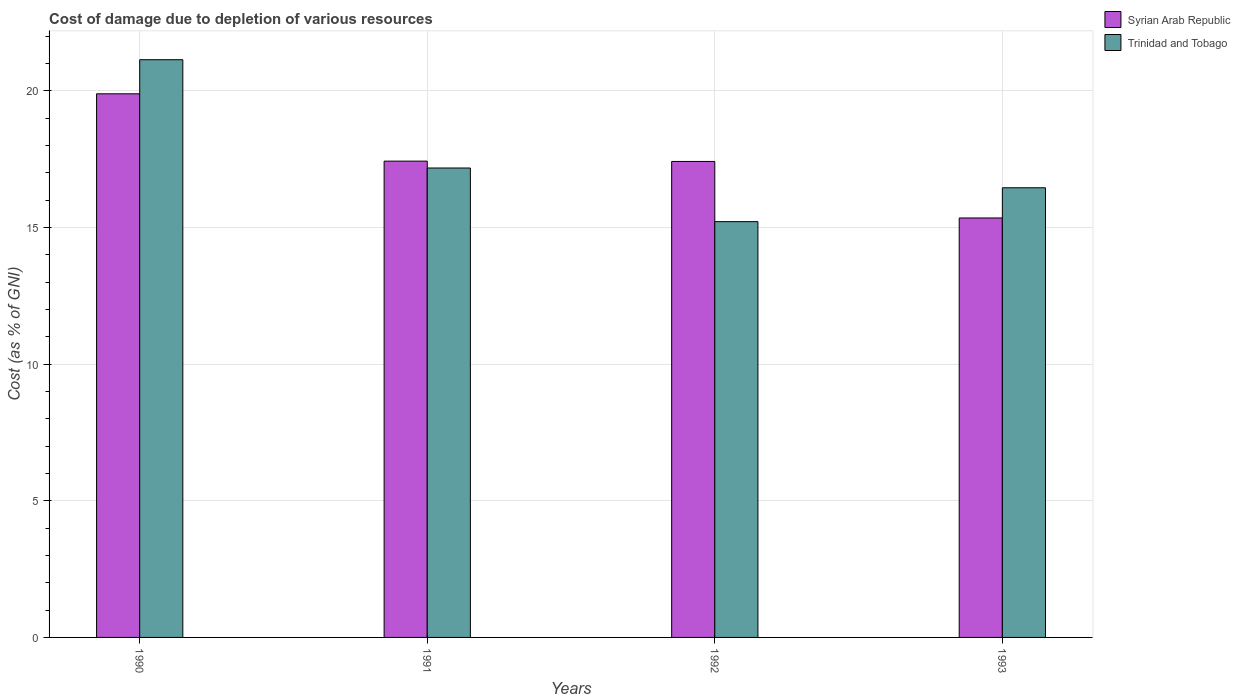How many groups of bars are there?
Provide a succinct answer. 4. Are the number of bars on each tick of the X-axis equal?
Give a very brief answer. Yes. How many bars are there on the 2nd tick from the right?
Keep it short and to the point. 2. What is the label of the 3rd group of bars from the left?
Ensure brevity in your answer.  1992. What is the cost of damage caused due to the depletion of various resources in Syrian Arab Republic in 1992?
Keep it short and to the point. 17.41. Across all years, what is the maximum cost of damage caused due to the depletion of various resources in Syrian Arab Republic?
Give a very brief answer. 19.89. Across all years, what is the minimum cost of damage caused due to the depletion of various resources in Syrian Arab Republic?
Provide a short and direct response. 15.34. In which year was the cost of damage caused due to the depletion of various resources in Trinidad and Tobago maximum?
Your answer should be very brief. 1990. What is the total cost of damage caused due to the depletion of various resources in Trinidad and Tobago in the graph?
Provide a succinct answer. 69.96. What is the difference between the cost of damage caused due to the depletion of various resources in Trinidad and Tobago in 1990 and that in 1993?
Make the answer very short. 4.68. What is the difference between the cost of damage caused due to the depletion of various resources in Syrian Arab Republic in 1993 and the cost of damage caused due to the depletion of various resources in Trinidad and Tobago in 1991?
Provide a short and direct response. -1.83. What is the average cost of damage caused due to the depletion of various resources in Trinidad and Tobago per year?
Give a very brief answer. 17.49. In the year 1993, what is the difference between the cost of damage caused due to the depletion of various resources in Trinidad and Tobago and cost of damage caused due to the depletion of various resources in Syrian Arab Republic?
Your response must be concise. 1.1. What is the ratio of the cost of damage caused due to the depletion of various resources in Trinidad and Tobago in 1990 to that in 1993?
Keep it short and to the point. 1.28. What is the difference between the highest and the second highest cost of damage caused due to the depletion of various resources in Trinidad and Tobago?
Give a very brief answer. 3.96. What is the difference between the highest and the lowest cost of damage caused due to the depletion of various resources in Trinidad and Tobago?
Ensure brevity in your answer.  5.92. In how many years, is the cost of damage caused due to the depletion of various resources in Syrian Arab Republic greater than the average cost of damage caused due to the depletion of various resources in Syrian Arab Republic taken over all years?
Give a very brief answer. 1. What does the 2nd bar from the left in 1992 represents?
Provide a succinct answer. Trinidad and Tobago. What does the 1st bar from the right in 1991 represents?
Offer a terse response. Trinidad and Tobago. What is the difference between two consecutive major ticks on the Y-axis?
Make the answer very short. 5. Are the values on the major ticks of Y-axis written in scientific E-notation?
Your answer should be compact. No. Does the graph contain grids?
Your response must be concise. Yes. How many legend labels are there?
Provide a short and direct response. 2. What is the title of the graph?
Provide a succinct answer. Cost of damage due to depletion of various resources. Does "Azerbaijan" appear as one of the legend labels in the graph?
Provide a succinct answer. No. What is the label or title of the X-axis?
Make the answer very short. Years. What is the label or title of the Y-axis?
Your answer should be compact. Cost (as % of GNI). What is the Cost (as % of GNI) in Syrian Arab Republic in 1990?
Your answer should be very brief. 19.89. What is the Cost (as % of GNI) of Trinidad and Tobago in 1990?
Provide a short and direct response. 21.13. What is the Cost (as % of GNI) of Syrian Arab Republic in 1991?
Give a very brief answer. 17.42. What is the Cost (as % of GNI) of Trinidad and Tobago in 1991?
Ensure brevity in your answer.  17.17. What is the Cost (as % of GNI) of Syrian Arab Republic in 1992?
Provide a short and direct response. 17.41. What is the Cost (as % of GNI) in Trinidad and Tobago in 1992?
Provide a succinct answer. 15.21. What is the Cost (as % of GNI) of Syrian Arab Republic in 1993?
Provide a short and direct response. 15.34. What is the Cost (as % of GNI) in Trinidad and Tobago in 1993?
Your answer should be compact. 16.45. Across all years, what is the maximum Cost (as % of GNI) in Syrian Arab Republic?
Ensure brevity in your answer.  19.89. Across all years, what is the maximum Cost (as % of GNI) of Trinidad and Tobago?
Your response must be concise. 21.13. Across all years, what is the minimum Cost (as % of GNI) in Syrian Arab Republic?
Offer a terse response. 15.34. Across all years, what is the minimum Cost (as % of GNI) in Trinidad and Tobago?
Provide a succinct answer. 15.21. What is the total Cost (as % of GNI) of Syrian Arab Republic in the graph?
Provide a succinct answer. 70.07. What is the total Cost (as % of GNI) in Trinidad and Tobago in the graph?
Provide a short and direct response. 69.96. What is the difference between the Cost (as % of GNI) in Syrian Arab Republic in 1990 and that in 1991?
Keep it short and to the point. 2.46. What is the difference between the Cost (as % of GNI) in Trinidad and Tobago in 1990 and that in 1991?
Offer a terse response. 3.96. What is the difference between the Cost (as % of GNI) of Syrian Arab Republic in 1990 and that in 1992?
Your answer should be very brief. 2.47. What is the difference between the Cost (as % of GNI) in Trinidad and Tobago in 1990 and that in 1992?
Keep it short and to the point. 5.92. What is the difference between the Cost (as % of GNI) in Syrian Arab Republic in 1990 and that in 1993?
Give a very brief answer. 4.54. What is the difference between the Cost (as % of GNI) of Trinidad and Tobago in 1990 and that in 1993?
Offer a very short reply. 4.68. What is the difference between the Cost (as % of GNI) of Syrian Arab Republic in 1991 and that in 1992?
Your response must be concise. 0.01. What is the difference between the Cost (as % of GNI) of Trinidad and Tobago in 1991 and that in 1992?
Offer a very short reply. 1.96. What is the difference between the Cost (as % of GNI) of Syrian Arab Republic in 1991 and that in 1993?
Your response must be concise. 2.08. What is the difference between the Cost (as % of GNI) in Trinidad and Tobago in 1991 and that in 1993?
Your response must be concise. 0.72. What is the difference between the Cost (as % of GNI) in Syrian Arab Republic in 1992 and that in 1993?
Your answer should be compact. 2.07. What is the difference between the Cost (as % of GNI) in Trinidad and Tobago in 1992 and that in 1993?
Give a very brief answer. -1.24. What is the difference between the Cost (as % of GNI) of Syrian Arab Republic in 1990 and the Cost (as % of GNI) of Trinidad and Tobago in 1991?
Provide a short and direct response. 2.71. What is the difference between the Cost (as % of GNI) in Syrian Arab Republic in 1990 and the Cost (as % of GNI) in Trinidad and Tobago in 1992?
Keep it short and to the point. 4.68. What is the difference between the Cost (as % of GNI) in Syrian Arab Republic in 1990 and the Cost (as % of GNI) in Trinidad and Tobago in 1993?
Your answer should be very brief. 3.44. What is the difference between the Cost (as % of GNI) in Syrian Arab Republic in 1991 and the Cost (as % of GNI) in Trinidad and Tobago in 1992?
Make the answer very short. 2.21. What is the difference between the Cost (as % of GNI) of Syrian Arab Republic in 1991 and the Cost (as % of GNI) of Trinidad and Tobago in 1993?
Offer a very short reply. 0.97. What is the difference between the Cost (as % of GNI) of Syrian Arab Republic in 1992 and the Cost (as % of GNI) of Trinidad and Tobago in 1993?
Offer a terse response. 0.96. What is the average Cost (as % of GNI) of Syrian Arab Republic per year?
Offer a terse response. 17.52. What is the average Cost (as % of GNI) of Trinidad and Tobago per year?
Keep it short and to the point. 17.49. In the year 1990, what is the difference between the Cost (as % of GNI) of Syrian Arab Republic and Cost (as % of GNI) of Trinidad and Tobago?
Your response must be concise. -1.25. In the year 1991, what is the difference between the Cost (as % of GNI) in Syrian Arab Republic and Cost (as % of GNI) in Trinidad and Tobago?
Ensure brevity in your answer.  0.25. In the year 1992, what is the difference between the Cost (as % of GNI) of Syrian Arab Republic and Cost (as % of GNI) of Trinidad and Tobago?
Give a very brief answer. 2.2. In the year 1993, what is the difference between the Cost (as % of GNI) in Syrian Arab Republic and Cost (as % of GNI) in Trinidad and Tobago?
Provide a short and direct response. -1.1. What is the ratio of the Cost (as % of GNI) in Syrian Arab Republic in 1990 to that in 1991?
Ensure brevity in your answer.  1.14. What is the ratio of the Cost (as % of GNI) in Trinidad and Tobago in 1990 to that in 1991?
Keep it short and to the point. 1.23. What is the ratio of the Cost (as % of GNI) in Syrian Arab Republic in 1990 to that in 1992?
Make the answer very short. 1.14. What is the ratio of the Cost (as % of GNI) of Trinidad and Tobago in 1990 to that in 1992?
Make the answer very short. 1.39. What is the ratio of the Cost (as % of GNI) of Syrian Arab Republic in 1990 to that in 1993?
Keep it short and to the point. 1.3. What is the ratio of the Cost (as % of GNI) of Trinidad and Tobago in 1990 to that in 1993?
Your answer should be compact. 1.28. What is the ratio of the Cost (as % of GNI) of Syrian Arab Republic in 1991 to that in 1992?
Your answer should be very brief. 1. What is the ratio of the Cost (as % of GNI) of Trinidad and Tobago in 1991 to that in 1992?
Provide a short and direct response. 1.13. What is the ratio of the Cost (as % of GNI) in Syrian Arab Republic in 1991 to that in 1993?
Your response must be concise. 1.14. What is the ratio of the Cost (as % of GNI) in Trinidad and Tobago in 1991 to that in 1993?
Offer a terse response. 1.04. What is the ratio of the Cost (as % of GNI) of Syrian Arab Republic in 1992 to that in 1993?
Keep it short and to the point. 1.13. What is the ratio of the Cost (as % of GNI) in Trinidad and Tobago in 1992 to that in 1993?
Provide a succinct answer. 0.92. What is the difference between the highest and the second highest Cost (as % of GNI) in Syrian Arab Republic?
Provide a short and direct response. 2.46. What is the difference between the highest and the second highest Cost (as % of GNI) in Trinidad and Tobago?
Offer a very short reply. 3.96. What is the difference between the highest and the lowest Cost (as % of GNI) of Syrian Arab Republic?
Ensure brevity in your answer.  4.54. What is the difference between the highest and the lowest Cost (as % of GNI) of Trinidad and Tobago?
Ensure brevity in your answer.  5.92. 